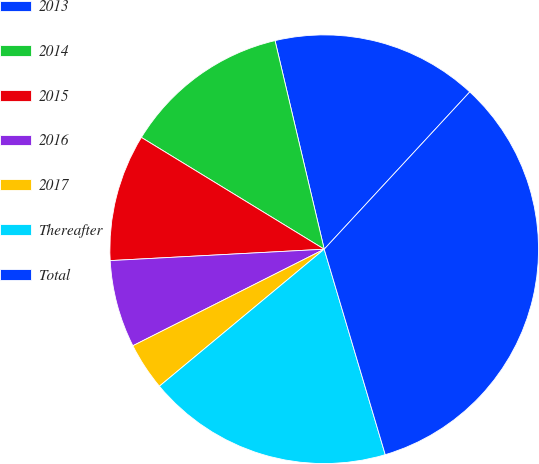Convert chart. <chart><loc_0><loc_0><loc_500><loc_500><pie_chart><fcel>2013<fcel>2014<fcel>2015<fcel>2016<fcel>2017<fcel>Thereafter<fcel>Total<nl><fcel>15.57%<fcel>12.58%<fcel>9.58%<fcel>6.59%<fcel>3.6%<fcel>18.56%<fcel>33.52%<nl></chart> 